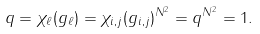<formula> <loc_0><loc_0><loc_500><loc_500>q = \chi _ { \ell } ( g _ { \ell } ) = \chi _ { i , j } ( g _ { i , j } ) ^ { N ^ { 2 } } = q ^ { N ^ { 2 } } = 1 .</formula> 